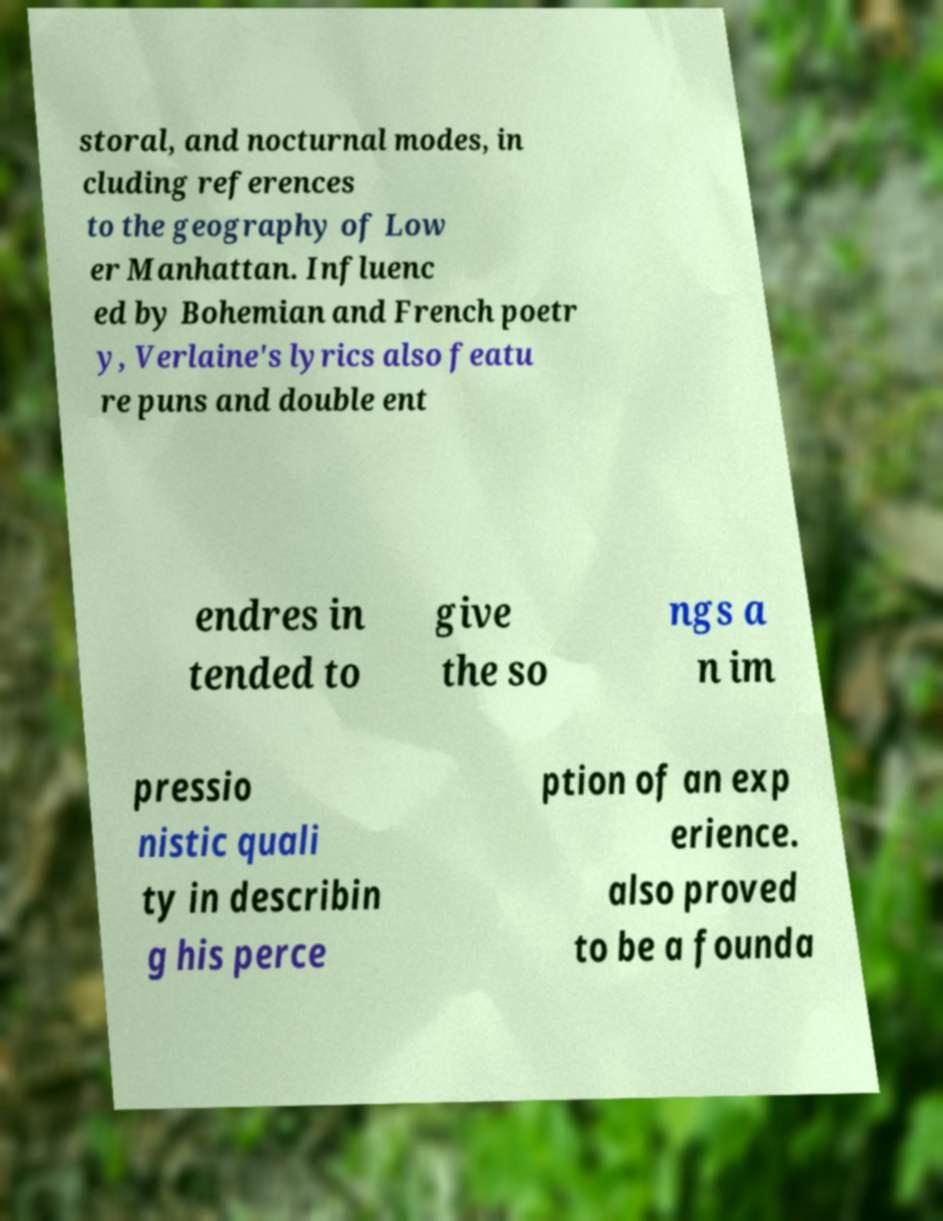Can you accurately transcribe the text from the provided image for me? storal, and nocturnal modes, in cluding references to the geography of Low er Manhattan. Influenc ed by Bohemian and French poetr y, Verlaine's lyrics also featu re puns and double ent endres in tended to give the so ngs a n im pressio nistic quali ty in describin g his perce ption of an exp erience. also proved to be a founda 